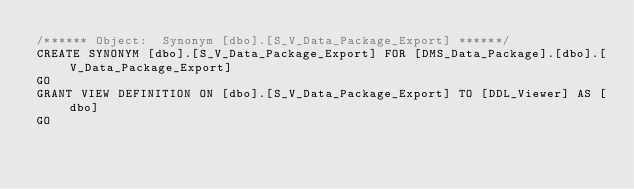Convert code to text. <code><loc_0><loc_0><loc_500><loc_500><_SQL_>/****** Object:  Synonym [dbo].[S_V_Data_Package_Export] ******/
CREATE SYNONYM [dbo].[S_V_Data_Package_Export] FOR [DMS_Data_Package].[dbo].[V_Data_Package_Export]
GO
GRANT VIEW DEFINITION ON [dbo].[S_V_Data_Package_Export] TO [DDL_Viewer] AS [dbo]
GO
</code> 